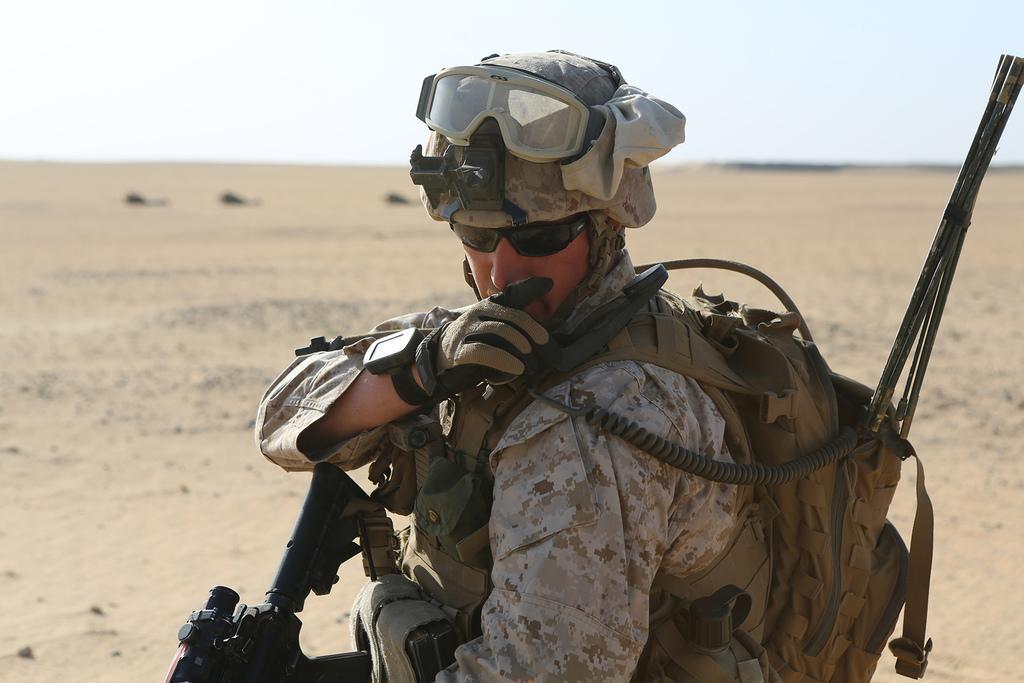Could you give a brief overview of what you see in this image? In this image, we can see a person in a military uniform wearing backpack and holding some object. Here we can see helmet, goggles and wire. Background there is a blur view. Here we can see the ground and sky. 